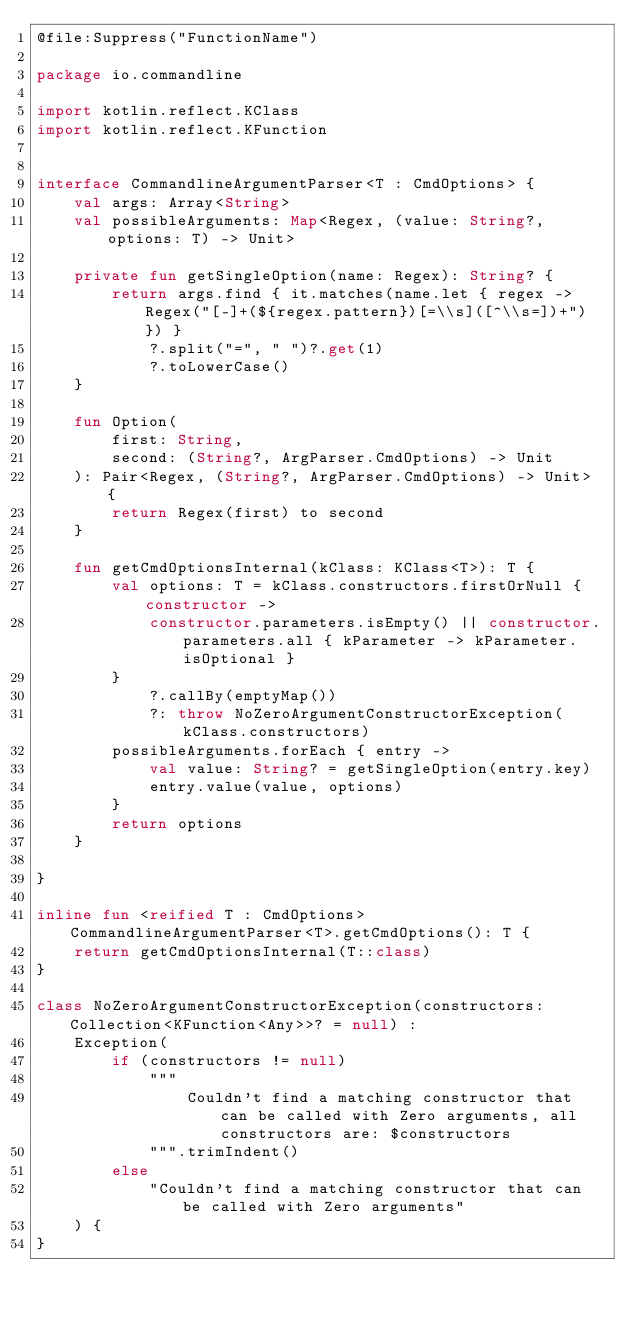Convert code to text. <code><loc_0><loc_0><loc_500><loc_500><_Kotlin_>@file:Suppress("FunctionName")

package io.commandline

import kotlin.reflect.KClass
import kotlin.reflect.KFunction


interface CommandlineArgumentParser<T : CmdOptions> {
    val args: Array<String>
    val possibleArguments: Map<Regex, (value: String?, options: T) -> Unit>

    private fun getSingleOption(name: Regex): String? {
        return args.find { it.matches(name.let { regex -> Regex("[-]+(${regex.pattern})[=\\s]([^\\s=])+") }) }
            ?.split("=", " ")?.get(1)
            ?.toLowerCase()
    }

    fun Option(
        first: String,
        second: (String?, ArgParser.CmdOptions) -> Unit
    ): Pair<Regex, (String?, ArgParser.CmdOptions) -> Unit> {
        return Regex(first) to second
    }

    fun getCmdOptionsInternal(kClass: KClass<T>): T {
        val options: T = kClass.constructors.firstOrNull { constructor ->
            constructor.parameters.isEmpty() || constructor.parameters.all { kParameter -> kParameter.isOptional }
        }
            ?.callBy(emptyMap())
            ?: throw NoZeroArgumentConstructorException(kClass.constructors)
        possibleArguments.forEach { entry ->
            val value: String? = getSingleOption(entry.key)
            entry.value(value, options)
        }
        return options
    }

}

inline fun <reified T : CmdOptions> CommandlineArgumentParser<T>.getCmdOptions(): T {
    return getCmdOptionsInternal(T::class)
}

class NoZeroArgumentConstructorException(constructors: Collection<KFunction<Any>>? = null) :
    Exception(
        if (constructors != null)
            """
                Couldn't find a matching constructor that can be called with Zero arguments, all constructors are: $constructors
            """.trimIndent()
        else
            "Couldn't find a matching constructor that can be called with Zero arguments"
    ) {
}
</code> 